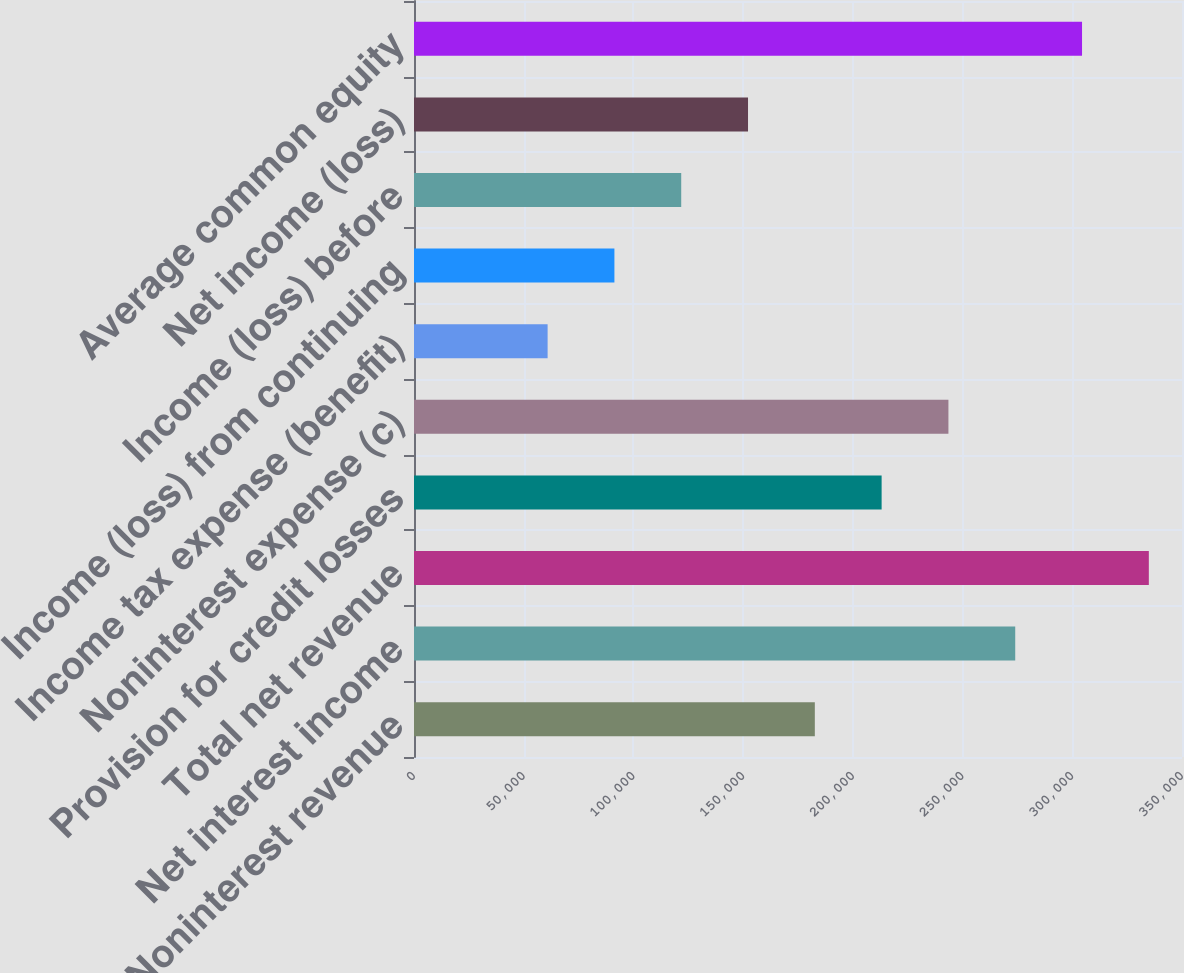Convert chart to OTSL. <chart><loc_0><loc_0><loc_500><loc_500><bar_chart><fcel>Noninterest revenue<fcel>Net interest income<fcel>Total net revenue<fcel>Provision for credit losses<fcel>Noninterest expense (c)<fcel>Income tax expense (benefit)<fcel>Income (loss) from continuing<fcel>Income (loss) before<fcel>Net income (loss)<fcel>Average common equity<nl><fcel>182667<fcel>273998<fcel>334886<fcel>213111<fcel>243555<fcel>60892.4<fcel>91336.1<fcel>121780<fcel>152224<fcel>304442<nl></chart> 